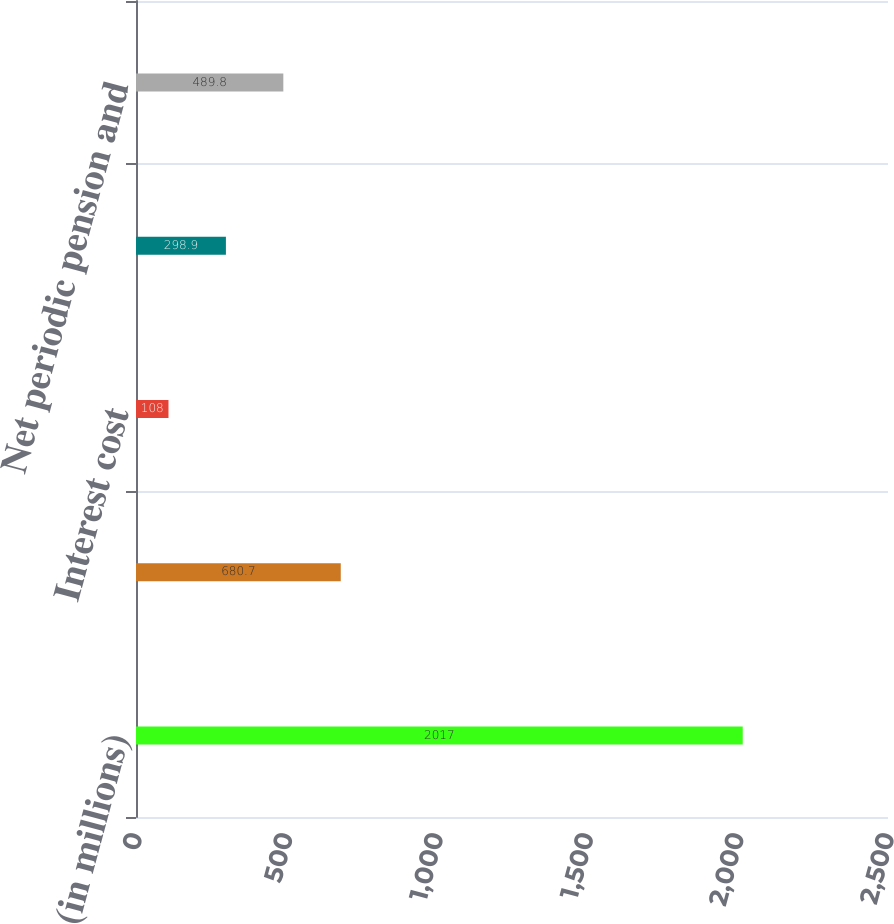Convert chart to OTSL. <chart><loc_0><loc_0><loc_500><loc_500><bar_chart><fcel>(in millions)<fcel>Service cost<fcel>Interest cost<fcel>Net losses<fcel>Net periodic pension and<nl><fcel>2017<fcel>680.7<fcel>108<fcel>298.9<fcel>489.8<nl></chart> 